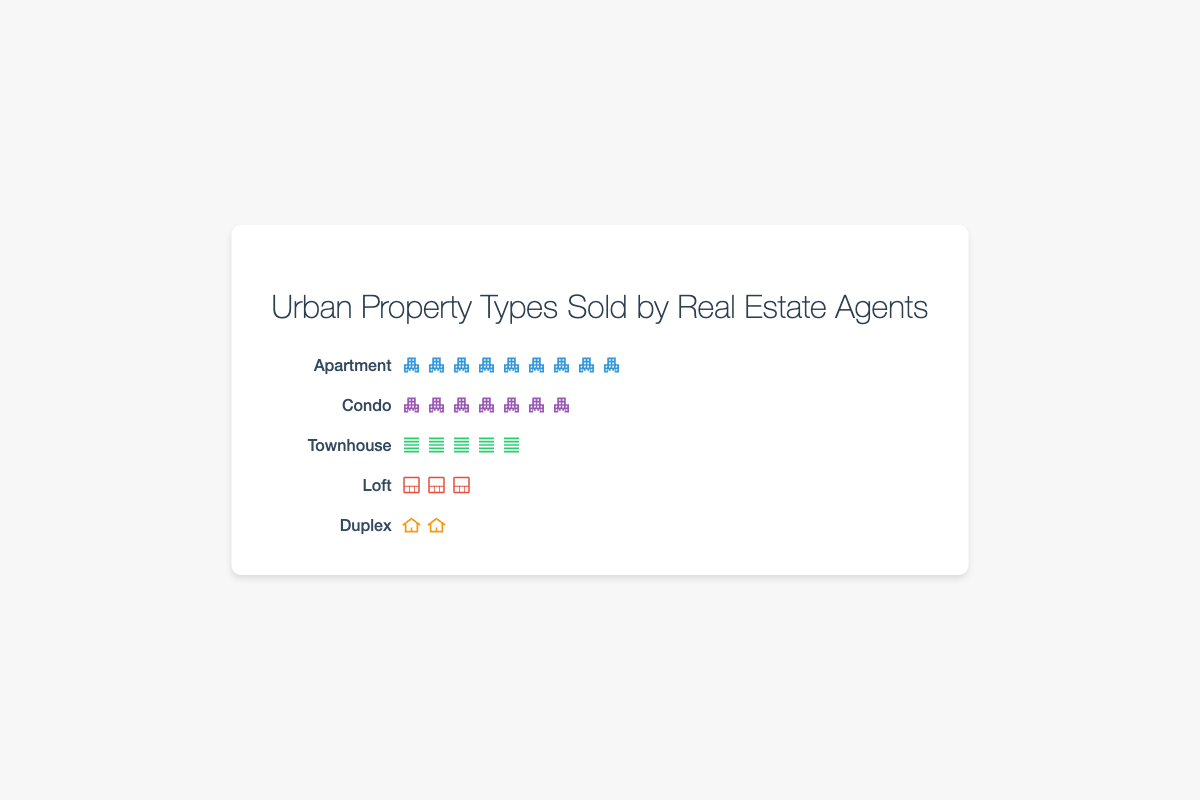How many icons represent apartments in the plot? Count the total number of apartment icons in the isotype plot. There are 9 icons of apartments, each representing 5 properties sold, so 9 x 5 = 45.
Answer: 45 Which property type has the least number of units sold? Identify which row has the fewest icons in the isotype plot. The duplex row has only 2 icons, indicating that duplexes have the fewest units sold.
Answer: Duplex How many more apartments were sold compared to lofts? Count the apartments and lofts icons: 9 for apartments and 3 for lofts. Each icon represents 5 properties sold. So, the difference is (9 - 3) * 5 = 30.
Answer: 30 What are the total units sold for townhouses and condos combined? Add up the count of townhouse and condo icons: 5 for townhouses and 7 for condos. Each icon represents 5 properties, so the total is (5 + 7) * 5 = 60.
Answer: 60 Which property type has the highest sales? Identify which row has the most icons in the isotype plot. The apartment row has 9 icons, the highest among all.
Answer: Apartment How does the number of condos compare to the number of duplexes? Count the condo and duplex icons: 7 for condos and 2 for duplexes. Each icon represents 5 properties sold. So, the comparison is (7 - 2) * 5 = 25.
Answer: 25 more What is the total number of units sold for all property types combined? Add up the count of all icons, which is 9 (apartments) + 7 (condos) + 5 (townhouses) + 3 (lofts) + 2 (duplexes) = 26. Each icon represents 5 properties sold, so 26 * 5 = 130.
Answer: 130 If the total number of lofts sold doubled, how many icons would represent them in the plot? There are currently 3 icons for lofts. If the number sold doubled, 3 * 2 = 6 icons would be needed. Each icon represents 5 properties sold.
Answer: 6 icons What is the average number of icons per property type? There are 5 property types and a total of 26 icons. The average is calculated as 26 / 5 = 5.2 icons per property type.
Answer: 5.2 How many more townhouses were sold compared to duplexes? Count the townhouse and duplex icons: 5 for townhouses and 2 for duplexes, so the difference is (5 - 2) * 5 = 15.
Answer: 15 